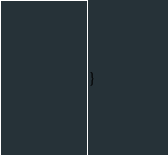Convert code to text. <code><loc_0><loc_0><loc_500><loc_500><_PHP_>}
</code> 